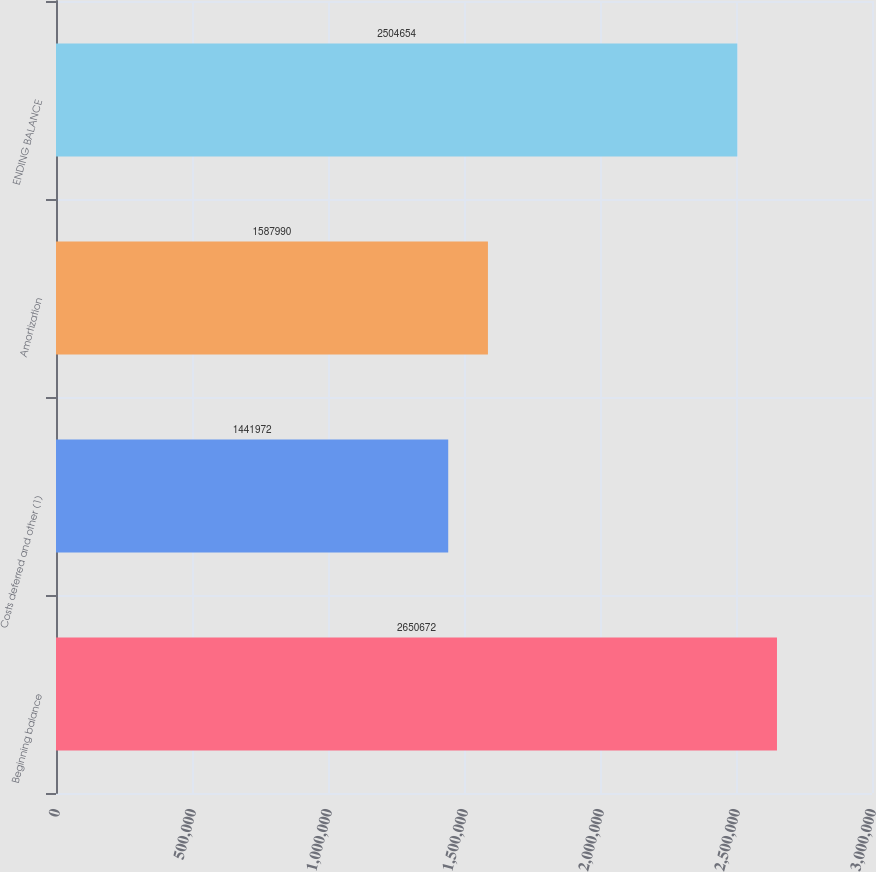<chart> <loc_0><loc_0><loc_500><loc_500><bar_chart><fcel>Beginning balance<fcel>Costs deferred and other (1)<fcel>Amortization<fcel>ENDING BALANCE<nl><fcel>2.65067e+06<fcel>1.44197e+06<fcel>1.58799e+06<fcel>2.50465e+06<nl></chart> 